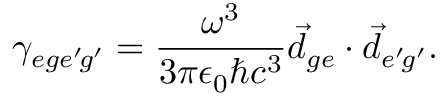<formula> <loc_0><loc_0><loc_500><loc_500>\gamma _ { e g e ^ { \prime } \, g ^ { \prime } } = \frac { \omega ^ { 3 } } { 3 \pi \epsilon _ { 0 } \hbar { c } ^ { 3 } } \vec { d } _ { g e } \cdot \vec { d } _ { e ^ { \prime } \, g ^ { \prime } } .</formula> 